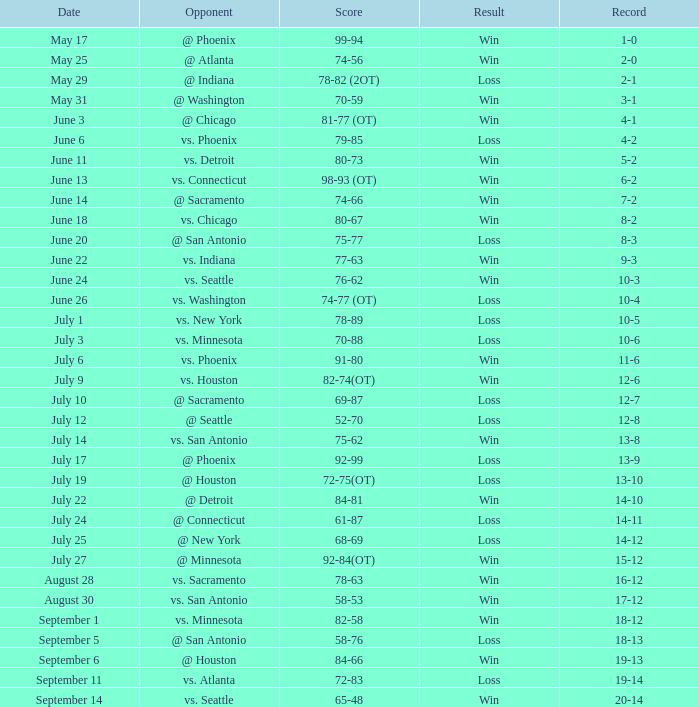What is the Opponent of the game with a Score of 74-66? @ Sacramento. 